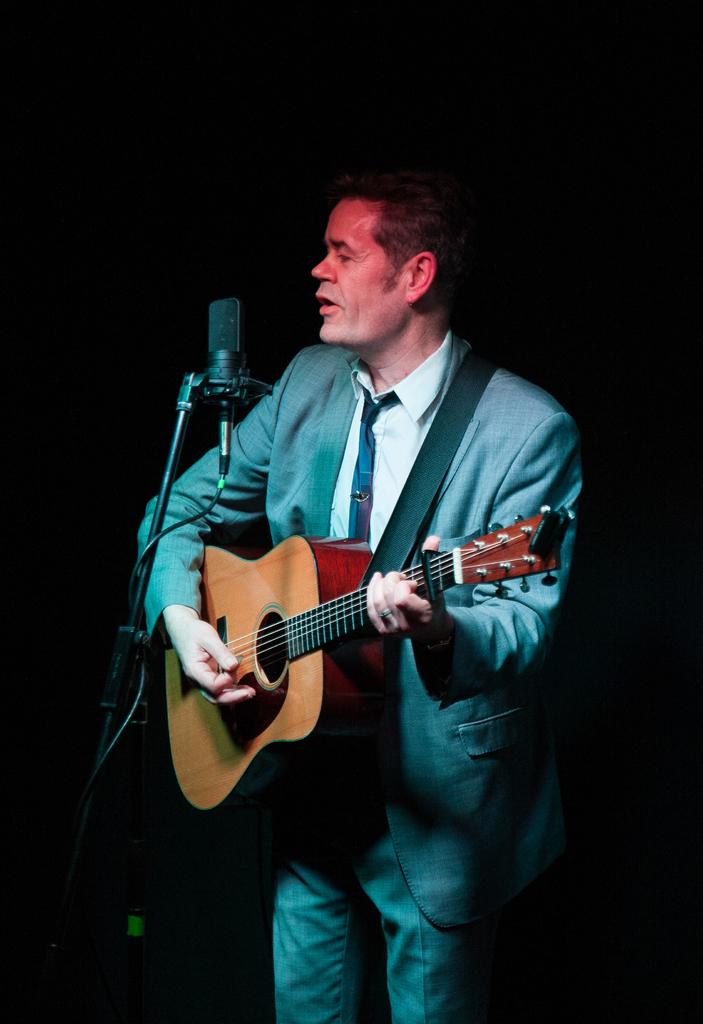What is the main subject of the image? The main subject of the image is a man. What is the man doing in the image? The man is standing in front of a microphone and playing a guitar. What type of ray can be seen emitting from the guitar in the image? There is no ray emitting from the guitar in the image. What liquid is visible in the image? There is no liquid present in the image. 